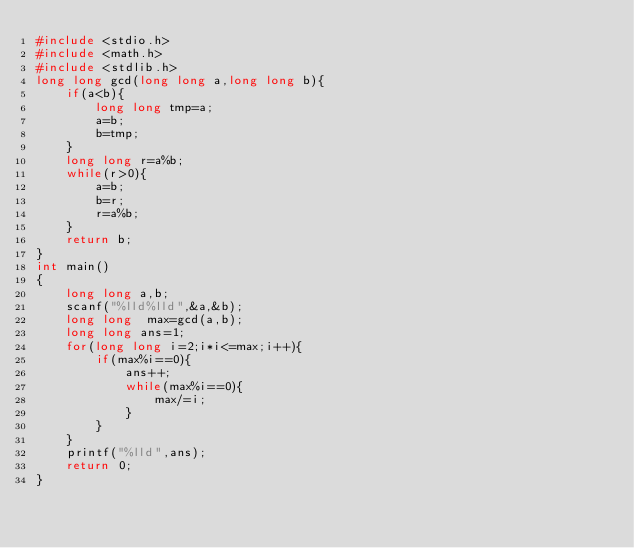Convert code to text. <code><loc_0><loc_0><loc_500><loc_500><_C_>#include <stdio.h>
#include <math.h>
#include <stdlib.h>
long long gcd(long long a,long long b){
    if(a<b){
        long long tmp=a;
        a=b;
        b=tmp;
    }
    long long r=a%b;
    while(r>0){
        a=b;
        b=r;
        r=a%b;
    }
    return b;
}
int main()
{   
    long long a,b;
    scanf("%lld%lld",&a,&b);
    long long  max=gcd(a,b);
    long long ans=1;
    for(long long i=2;i*i<=max;i++){
        if(max%i==0){
            ans++;
            while(max%i==0){
                max/=i;
            }
        }
    }
    printf("%lld",ans);
    return 0;
}
</code> 